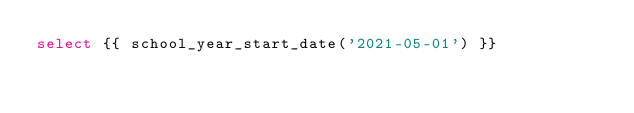Convert code to text. <code><loc_0><loc_0><loc_500><loc_500><_SQL_>select {{ school_year_start_date('2021-05-01') }}
</code> 